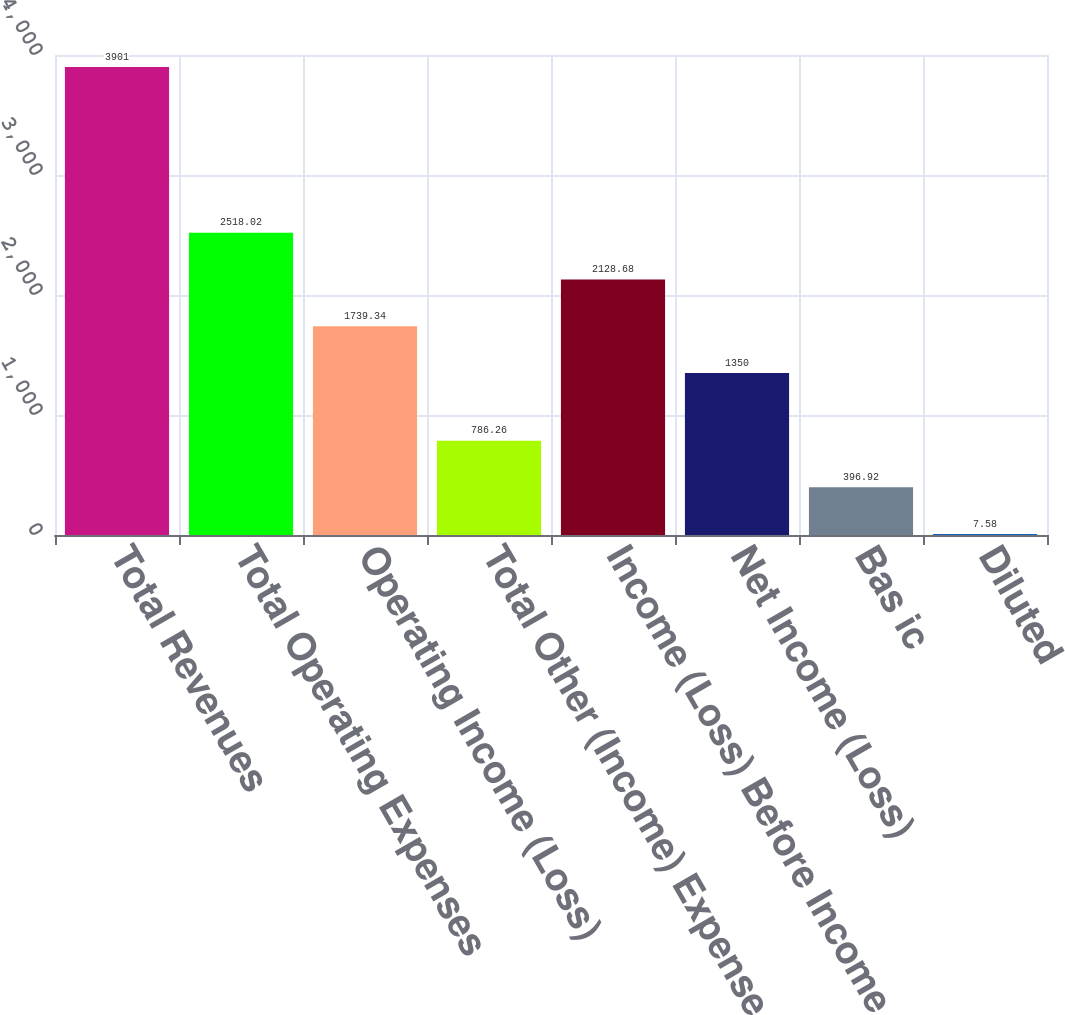<chart> <loc_0><loc_0><loc_500><loc_500><bar_chart><fcel>Total Revenues<fcel>Total Operating Expenses<fcel>Operating Income (Loss)<fcel>Total Other (Income) Expense<fcel>Income (Loss) Before Income<fcel>Net Income (Loss)<fcel>Bas ic<fcel>Diluted<nl><fcel>3901<fcel>2518.02<fcel>1739.34<fcel>786.26<fcel>2128.68<fcel>1350<fcel>396.92<fcel>7.58<nl></chart> 